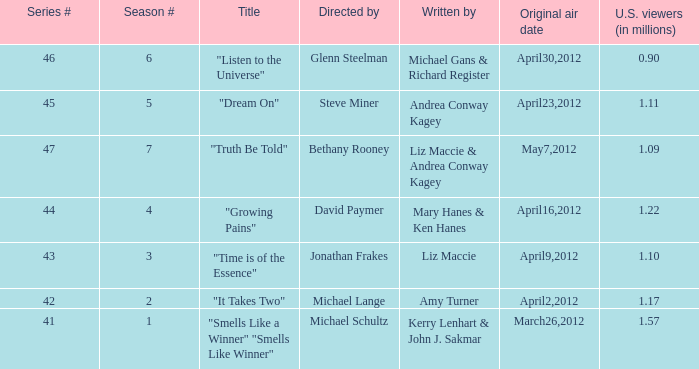When was the first broadcast of the episode titled "Truth Be Told"? May7,2012. 